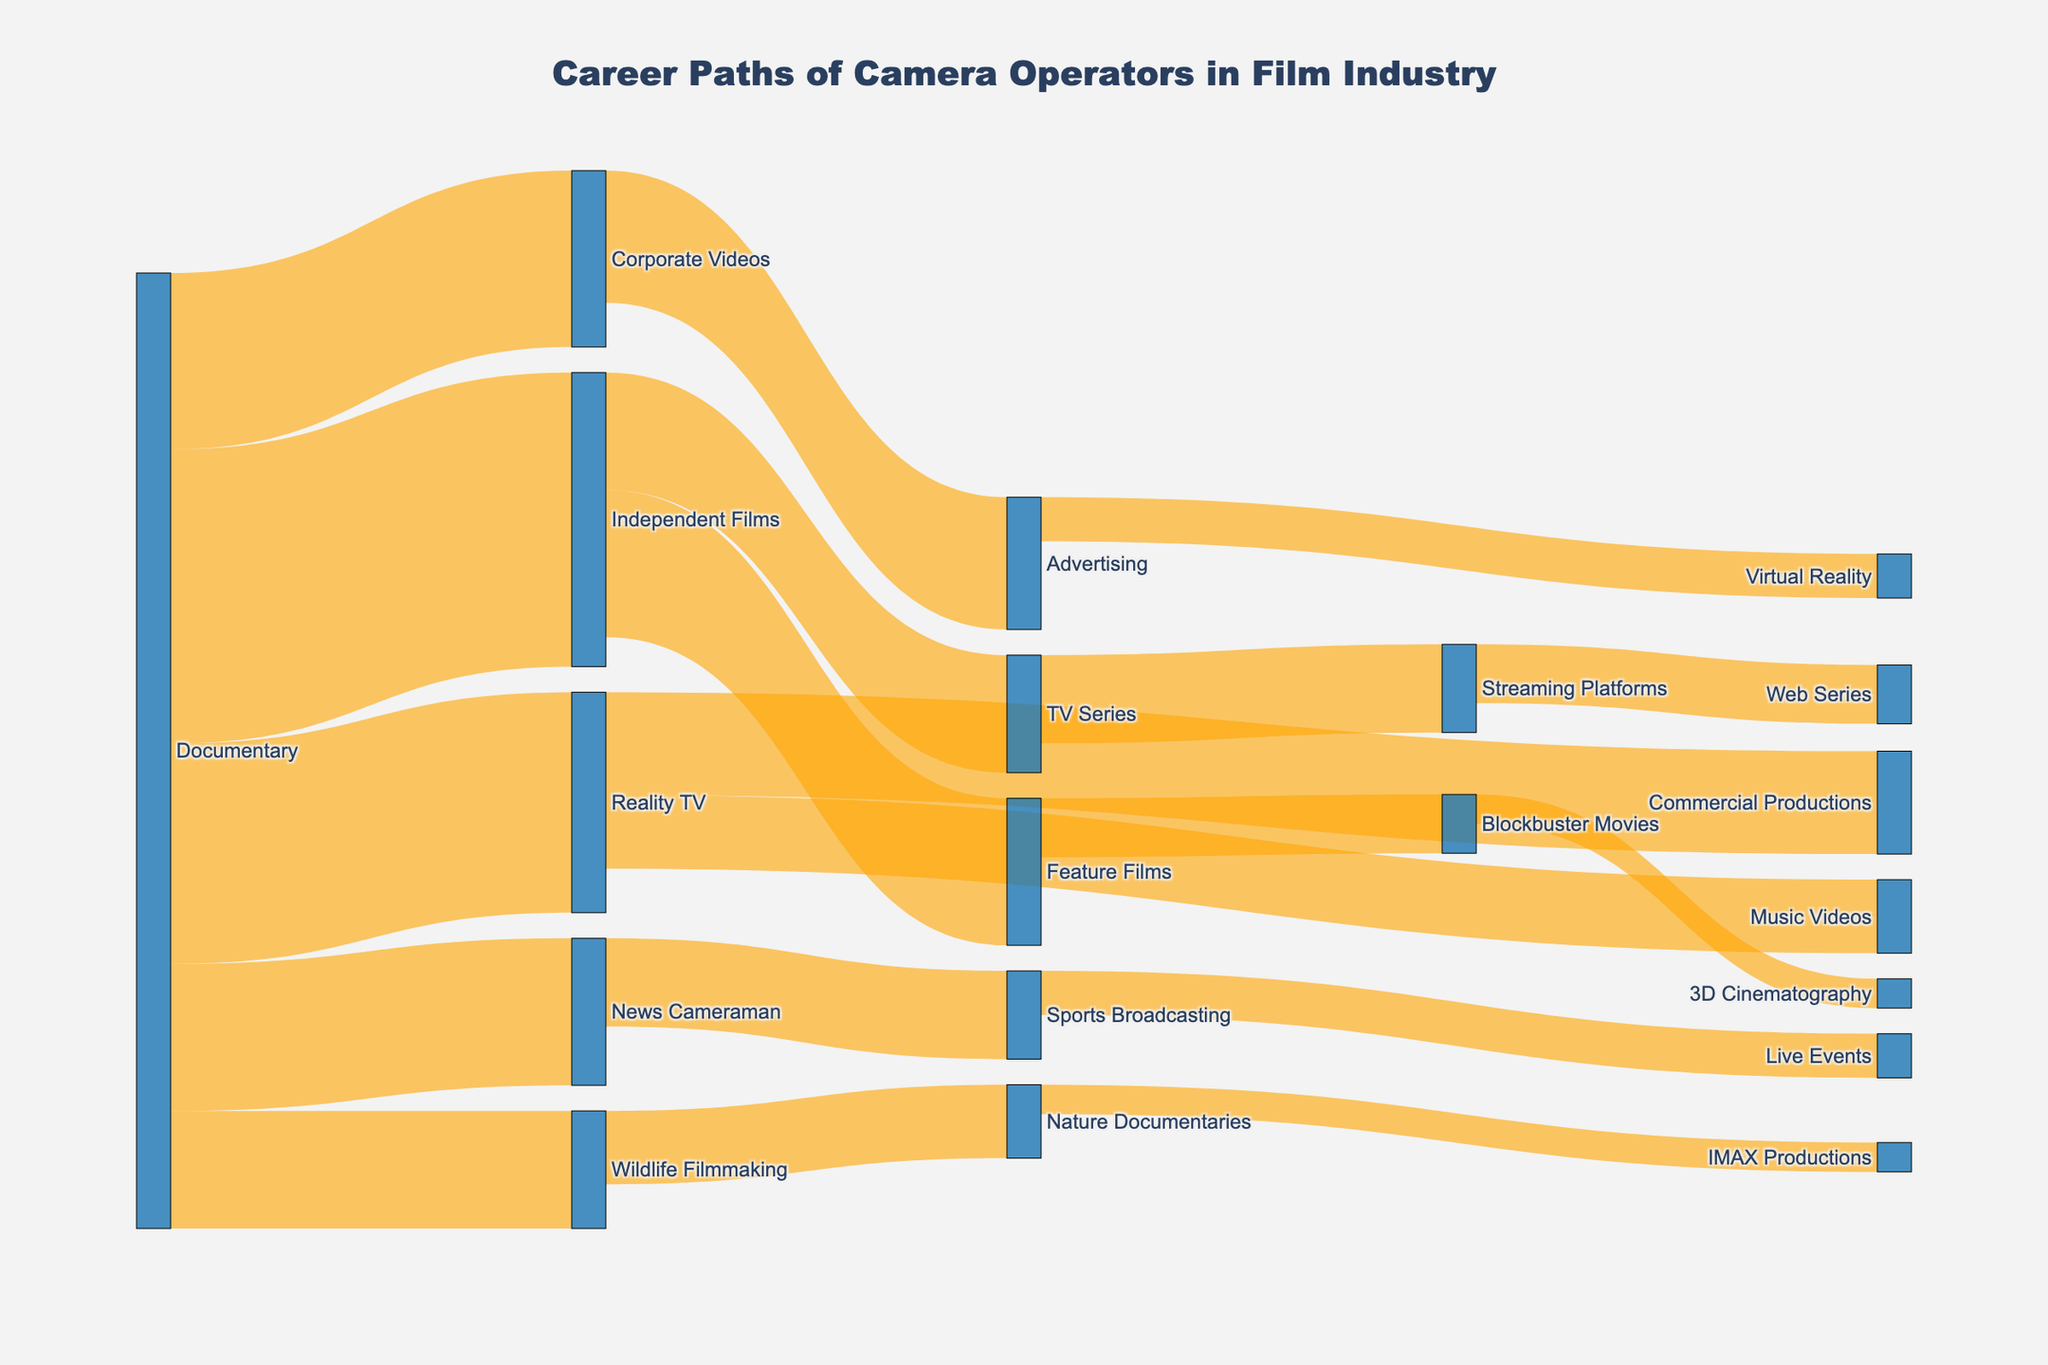How many career paths are there from documentaries to other categories? Observing the figure, we see lines moving from 'Documentary' to several paths. Counting these, we have paths to 'Reality TV', 'Independent Films', 'News Cameraman', 'Wildlife Filmmaking', and 'Corporate Videos'. These are 5 paths in total.
Answer: 5 Which category has the highest number of transitions from documentaries? Looking at the lines flowing out from 'Documentary', the path to 'Independent Films' appears thickest, representing the highest number. The exact number on this line is 20.
Answer: Independent Films What is the total number of camera operators transitioning from 'Reality TV' to other categories? The flows from 'Reality TV' are to 'Commercial Productions' (7) and 'Music Videos' (5). Summing these values, we get 7 + 5 = 12.
Answer: 12 Compare the number of transitions from 'Independent Films' to 'Feature Films' and 'TV Series'. Which is greater and by how much? From 'Independent Films', the transitions to 'Feature Films' are 10 and to 'TV Series' are 8. The difference is 10 - 8 = 2. Therefore, the transitions to 'Feature Films' are greater by 2.
Answer: Feature Films, by 2 How many unique categories are listed in the diagram? Counting each unique node from 'Documentary', 'Reality TV', 'Independent Films', 'News Cameraman', 'Wildlife Filmmaking', 'Corporate Videos', 'Commercial Productions', 'Music Videos', 'Feature Films', 'TV Series', 'Sports Broadcasting', 'Nature Documentaries', 'Advertising', 'Blockbuster Movies', 'Streaming Platforms', 'Live Events', 'IMAX Productions', 'Virtual Reality', '3D Cinematography', and 'Web Series', there are 19 unique categories.
Answer: 19 What is the smallest value represented in the transitions from 'Documentary'? The flows out of 'Documentary' show values 15, 20, 10, 8, and 12. Among these, the smallest value is 8 to 'Wildlife Filmmaking'.
Answer: 8 Identify which path has a value of 6 and specify both the source and target. Looking at the values on the diagram, two flows have the value of 6: one from 'News Cameraman' to 'Sports Broadcasting' and another from 'TV Series' to 'Streaming Platforms'. These paths confirm the value of 6.
Answer: News Cameraman to Sports Broadcasting; TV Series to Streaming Platforms How many transitions result in streaming platforms and web series combined? The paths to 'Streaming Platforms' include 6 from 'TV Series', and to 'Web Series' include 4 from 'Streaming Platforms'. Summing the two values, we get 6 + 4 = 10.
Answer: 10 Which category transitions to 'Virtual Reality', and what is the value? Observing the flow towards 'Virtual Reality' reveals only one transition, coming from 'Advertising' with a value of 3.
Answer: Advertising, 3 